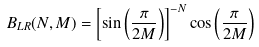Convert formula to latex. <formula><loc_0><loc_0><loc_500><loc_500>B _ { L R } ( N , M ) = \left [ \sin \left ( \frac { \pi } { 2 M } \right ) \right ] ^ { - N } \cos \left ( \frac { \pi } { 2 M } \right )</formula> 